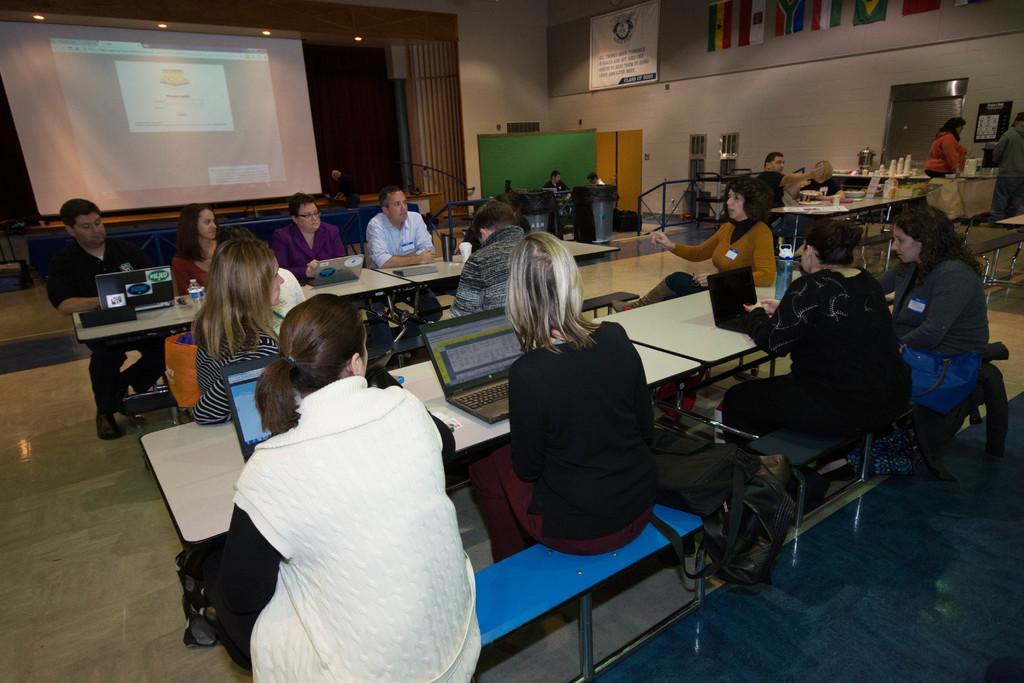In one or two sentences, can you explain what this image depicts? There are group of people sitting on the chairs. This is a table with laptops and water bottle on it. I can see a woman standing. This looks like a screen with a display. And here is a banner hanging to the wall. I can see flags attached to the wall. 